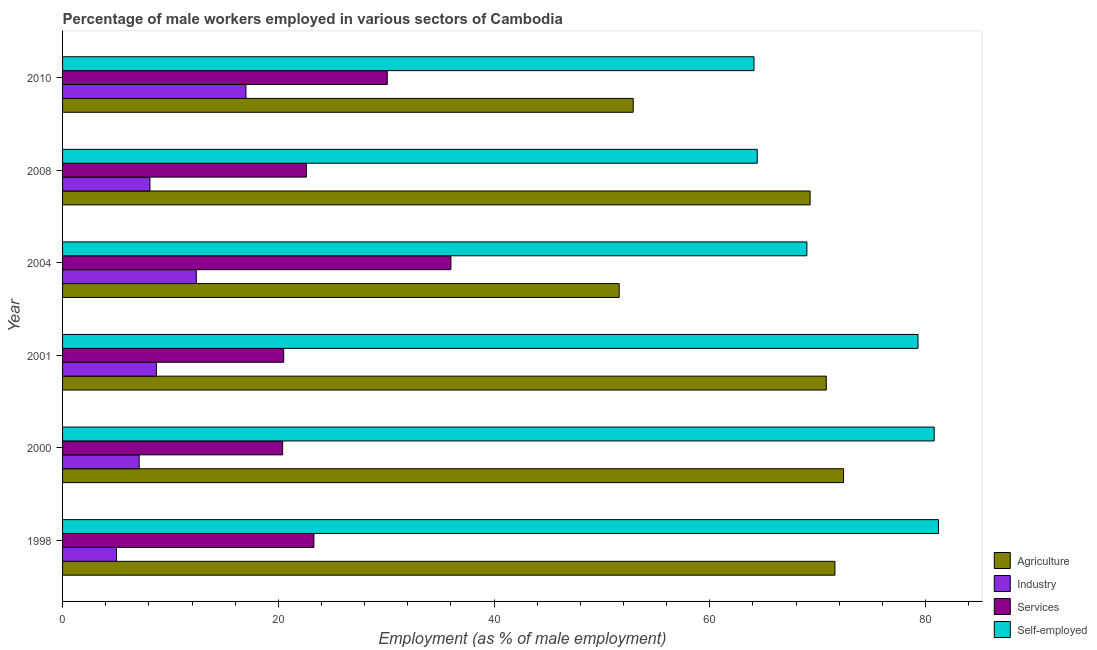Are the number of bars per tick equal to the number of legend labels?
Provide a succinct answer. Yes. How many bars are there on the 6th tick from the bottom?
Ensure brevity in your answer.  4. In how many cases, is the number of bars for a given year not equal to the number of legend labels?
Your answer should be very brief. 0. Across all years, what is the minimum percentage of male workers in agriculture?
Provide a succinct answer. 51.6. What is the total percentage of male workers in industry in the graph?
Your answer should be compact. 58.3. What is the difference between the percentage of male workers in services in 2008 and that in 2010?
Your response must be concise. -7.5. What is the difference between the percentage of male workers in services in 2000 and the percentage of self employed male workers in 2010?
Your response must be concise. -43.7. What is the average percentage of male workers in services per year?
Offer a terse response. 25.48. In the year 2008, what is the difference between the percentage of male workers in industry and percentage of male workers in agriculture?
Keep it short and to the point. -61.2. What is the ratio of the percentage of male workers in industry in 2004 to that in 2008?
Give a very brief answer. 1.53. Is the percentage of male workers in industry in 2000 less than that in 2004?
Offer a terse response. Yes. Is the difference between the percentage of male workers in services in 1998 and 2001 greater than the difference between the percentage of male workers in industry in 1998 and 2001?
Provide a short and direct response. Yes. What is the difference between the highest and the lowest percentage of self employed male workers?
Make the answer very short. 17.1. In how many years, is the percentage of male workers in industry greater than the average percentage of male workers in industry taken over all years?
Offer a terse response. 2. Is the sum of the percentage of male workers in industry in 1998 and 2010 greater than the maximum percentage of male workers in services across all years?
Offer a very short reply. No. Is it the case that in every year, the sum of the percentage of male workers in services and percentage of self employed male workers is greater than the sum of percentage of male workers in agriculture and percentage of male workers in industry?
Make the answer very short. Yes. What does the 2nd bar from the top in 2001 represents?
Your answer should be compact. Services. What does the 1st bar from the bottom in 2004 represents?
Your answer should be very brief. Agriculture. Are all the bars in the graph horizontal?
Offer a very short reply. Yes. Are the values on the major ticks of X-axis written in scientific E-notation?
Provide a succinct answer. No. Does the graph contain any zero values?
Offer a terse response. No. How many legend labels are there?
Give a very brief answer. 4. How are the legend labels stacked?
Offer a very short reply. Vertical. What is the title of the graph?
Offer a very short reply. Percentage of male workers employed in various sectors of Cambodia. Does "Gender equality" appear as one of the legend labels in the graph?
Your answer should be very brief. No. What is the label or title of the X-axis?
Provide a succinct answer. Employment (as % of male employment). What is the label or title of the Y-axis?
Offer a very short reply. Year. What is the Employment (as % of male employment) of Agriculture in 1998?
Provide a short and direct response. 71.6. What is the Employment (as % of male employment) of Industry in 1998?
Keep it short and to the point. 5. What is the Employment (as % of male employment) of Services in 1998?
Your answer should be very brief. 23.3. What is the Employment (as % of male employment) of Self-employed in 1998?
Your answer should be very brief. 81.2. What is the Employment (as % of male employment) of Agriculture in 2000?
Ensure brevity in your answer.  72.4. What is the Employment (as % of male employment) in Industry in 2000?
Keep it short and to the point. 7.1. What is the Employment (as % of male employment) of Services in 2000?
Your response must be concise. 20.4. What is the Employment (as % of male employment) of Self-employed in 2000?
Ensure brevity in your answer.  80.8. What is the Employment (as % of male employment) of Agriculture in 2001?
Provide a succinct answer. 70.8. What is the Employment (as % of male employment) in Industry in 2001?
Ensure brevity in your answer.  8.7. What is the Employment (as % of male employment) of Self-employed in 2001?
Offer a very short reply. 79.3. What is the Employment (as % of male employment) of Agriculture in 2004?
Your answer should be very brief. 51.6. What is the Employment (as % of male employment) of Industry in 2004?
Give a very brief answer. 12.4. What is the Employment (as % of male employment) in Services in 2004?
Give a very brief answer. 36. What is the Employment (as % of male employment) in Self-employed in 2004?
Offer a terse response. 69. What is the Employment (as % of male employment) of Agriculture in 2008?
Your response must be concise. 69.3. What is the Employment (as % of male employment) in Industry in 2008?
Make the answer very short. 8.1. What is the Employment (as % of male employment) in Services in 2008?
Ensure brevity in your answer.  22.6. What is the Employment (as % of male employment) in Self-employed in 2008?
Provide a succinct answer. 64.4. What is the Employment (as % of male employment) in Agriculture in 2010?
Give a very brief answer. 52.9. What is the Employment (as % of male employment) of Services in 2010?
Provide a short and direct response. 30.1. What is the Employment (as % of male employment) of Self-employed in 2010?
Ensure brevity in your answer.  64.1. Across all years, what is the maximum Employment (as % of male employment) in Agriculture?
Keep it short and to the point. 72.4. Across all years, what is the maximum Employment (as % of male employment) of Industry?
Offer a terse response. 17. Across all years, what is the maximum Employment (as % of male employment) in Self-employed?
Your answer should be compact. 81.2. Across all years, what is the minimum Employment (as % of male employment) in Agriculture?
Provide a short and direct response. 51.6. Across all years, what is the minimum Employment (as % of male employment) of Industry?
Provide a succinct answer. 5. Across all years, what is the minimum Employment (as % of male employment) in Services?
Give a very brief answer. 20.4. Across all years, what is the minimum Employment (as % of male employment) of Self-employed?
Your response must be concise. 64.1. What is the total Employment (as % of male employment) in Agriculture in the graph?
Make the answer very short. 388.6. What is the total Employment (as % of male employment) in Industry in the graph?
Your response must be concise. 58.3. What is the total Employment (as % of male employment) of Services in the graph?
Keep it short and to the point. 152.9. What is the total Employment (as % of male employment) of Self-employed in the graph?
Keep it short and to the point. 438.8. What is the difference between the Employment (as % of male employment) in Agriculture in 1998 and that in 2000?
Make the answer very short. -0.8. What is the difference between the Employment (as % of male employment) of Industry in 1998 and that in 2000?
Give a very brief answer. -2.1. What is the difference between the Employment (as % of male employment) of Services in 1998 and that in 2000?
Your response must be concise. 2.9. What is the difference between the Employment (as % of male employment) of Self-employed in 1998 and that in 2000?
Offer a very short reply. 0.4. What is the difference between the Employment (as % of male employment) in Services in 1998 and that in 2001?
Ensure brevity in your answer.  2.8. What is the difference between the Employment (as % of male employment) in Self-employed in 1998 and that in 2001?
Offer a terse response. 1.9. What is the difference between the Employment (as % of male employment) of Agriculture in 1998 and that in 2004?
Offer a very short reply. 20. What is the difference between the Employment (as % of male employment) of Services in 1998 and that in 2004?
Your response must be concise. -12.7. What is the difference between the Employment (as % of male employment) in Industry in 1998 and that in 2008?
Your answer should be very brief. -3.1. What is the difference between the Employment (as % of male employment) of Services in 1998 and that in 2008?
Keep it short and to the point. 0.7. What is the difference between the Employment (as % of male employment) in Industry in 1998 and that in 2010?
Your response must be concise. -12. What is the difference between the Employment (as % of male employment) of Self-employed in 1998 and that in 2010?
Provide a short and direct response. 17.1. What is the difference between the Employment (as % of male employment) of Agriculture in 2000 and that in 2001?
Keep it short and to the point. 1.6. What is the difference between the Employment (as % of male employment) in Industry in 2000 and that in 2001?
Offer a very short reply. -1.6. What is the difference between the Employment (as % of male employment) of Self-employed in 2000 and that in 2001?
Your response must be concise. 1.5. What is the difference between the Employment (as % of male employment) of Agriculture in 2000 and that in 2004?
Make the answer very short. 20.8. What is the difference between the Employment (as % of male employment) in Industry in 2000 and that in 2004?
Provide a succinct answer. -5.3. What is the difference between the Employment (as % of male employment) in Services in 2000 and that in 2004?
Offer a terse response. -15.6. What is the difference between the Employment (as % of male employment) of Agriculture in 2000 and that in 2008?
Your answer should be very brief. 3.1. What is the difference between the Employment (as % of male employment) in Services in 2000 and that in 2010?
Your response must be concise. -9.7. What is the difference between the Employment (as % of male employment) of Self-employed in 2000 and that in 2010?
Provide a succinct answer. 16.7. What is the difference between the Employment (as % of male employment) of Agriculture in 2001 and that in 2004?
Your answer should be compact. 19.2. What is the difference between the Employment (as % of male employment) of Services in 2001 and that in 2004?
Provide a succinct answer. -15.5. What is the difference between the Employment (as % of male employment) of Agriculture in 2001 and that in 2008?
Your answer should be very brief. 1.5. What is the difference between the Employment (as % of male employment) of Industry in 2001 and that in 2008?
Offer a very short reply. 0.6. What is the difference between the Employment (as % of male employment) in Services in 2001 and that in 2008?
Make the answer very short. -2.1. What is the difference between the Employment (as % of male employment) of Self-employed in 2001 and that in 2008?
Provide a succinct answer. 14.9. What is the difference between the Employment (as % of male employment) of Self-employed in 2001 and that in 2010?
Provide a succinct answer. 15.2. What is the difference between the Employment (as % of male employment) in Agriculture in 2004 and that in 2008?
Your response must be concise. -17.7. What is the difference between the Employment (as % of male employment) in Self-employed in 2004 and that in 2008?
Provide a short and direct response. 4.6. What is the difference between the Employment (as % of male employment) in Self-employed in 2004 and that in 2010?
Keep it short and to the point. 4.9. What is the difference between the Employment (as % of male employment) in Agriculture in 2008 and that in 2010?
Offer a terse response. 16.4. What is the difference between the Employment (as % of male employment) of Industry in 2008 and that in 2010?
Your answer should be compact. -8.9. What is the difference between the Employment (as % of male employment) of Agriculture in 1998 and the Employment (as % of male employment) of Industry in 2000?
Give a very brief answer. 64.5. What is the difference between the Employment (as % of male employment) in Agriculture in 1998 and the Employment (as % of male employment) in Services in 2000?
Give a very brief answer. 51.2. What is the difference between the Employment (as % of male employment) in Industry in 1998 and the Employment (as % of male employment) in Services in 2000?
Keep it short and to the point. -15.4. What is the difference between the Employment (as % of male employment) of Industry in 1998 and the Employment (as % of male employment) of Self-employed in 2000?
Your answer should be compact. -75.8. What is the difference between the Employment (as % of male employment) in Services in 1998 and the Employment (as % of male employment) in Self-employed in 2000?
Offer a very short reply. -57.5. What is the difference between the Employment (as % of male employment) of Agriculture in 1998 and the Employment (as % of male employment) of Industry in 2001?
Ensure brevity in your answer.  62.9. What is the difference between the Employment (as % of male employment) of Agriculture in 1998 and the Employment (as % of male employment) of Services in 2001?
Your answer should be very brief. 51.1. What is the difference between the Employment (as % of male employment) in Agriculture in 1998 and the Employment (as % of male employment) in Self-employed in 2001?
Make the answer very short. -7.7. What is the difference between the Employment (as % of male employment) in Industry in 1998 and the Employment (as % of male employment) in Services in 2001?
Provide a short and direct response. -15.5. What is the difference between the Employment (as % of male employment) in Industry in 1998 and the Employment (as % of male employment) in Self-employed in 2001?
Keep it short and to the point. -74.3. What is the difference between the Employment (as % of male employment) in Services in 1998 and the Employment (as % of male employment) in Self-employed in 2001?
Offer a very short reply. -56. What is the difference between the Employment (as % of male employment) of Agriculture in 1998 and the Employment (as % of male employment) of Industry in 2004?
Your response must be concise. 59.2. What is the difference between the Employment (as % of male employment) in Agriculture in 1998 and the Employment (as % of male employment) in Services in 2004?
Your response must be concise. 35.6. What is the difference between the Employment (as % of male employment) in Industry in 1998 and the Employment (as % of male employment) in Services in 2004?
Make the answer very short. -31. What is the difference between the Employment (as % of male employment) in Industry in 1998 and the Employment (as % of male employment) in Self-employed in 2004?
Your answer should be very brief. -64. What is the difference between the Employment (as % of male employment) in Services in 1998 and the Employment (as % of male employment) in Self-employed in 2004?
Offer a terse response. -45.7. What is the difference between the Employment (as % of male employment) of Agriculture in 1998 and the Employment (as % of male employment) of Industry in 2008?
Keep it short and to the point. 63.5. What is the difference between the Employment (as % of male employment) in Agriculture in 1998 and the Employment (as % of male employment) in Self-employed in 2008?
Provide a short and direct response. 7.2. What is the difference between the Employment (as % of male employment) of Industry in 1998 and the Employment (as % of male employment) of Services in 2008?
Offer a terse response. -17.6. What is the difference between the Employment (as % of male employment) in Industry in 1998 and the Employment (as % of male employment) in Self-employed in 2008?
Provide a succinct answer. -59.4. What is the difference between the Employment (as % of male employment) in Services in 1998 and the Employment (as % of male employment) in Self-employed in 2008?
Ensure brevity in your answer.  -41.1. What is the difference between the Employment (as % of male employment) of Agriculture in 1998 and the Employment (as % of male employment) of Industry in 2010?
Ensure brevity in your answer.  54.6. What is the difference between the Employment (as % of male employment) in Agriculture in 1998 and the Employment (as % of male employment) in Services in 2010?
Your response must be concise. 41.5. What is the difference between the Employment (as % of male employment) of Industry in 1998 and the Employment (as % of male employment) of Services in 2010?
Your response must be concise. -25.1. What is the difference between the Employment (as % of male employment) of Industry in 1998 and the Employment (as % of male employment) of Self-employed in 2010?
Your response must be concise. -59.1. What is the difference between the Employment (as % of male employment) of Services in 1998 and the Employment (as % of male employment) of Self-employed in 2010?
Give a very brief answer. -40.8. What is the difference between the Employment (as % of male employment) in Agriculture in 2000 and the Employment (as % of male employment) in Industry in 2001?
Offer a terse response. 63.7. What is the difference between the Employment (as % of male employment) in Agriculture in 2000 and the Employment (as % of male employment) in Services in 2001?
Provide a short and direct response. 51.9. What is the difference between the Employment (as % of male employment) of Agriculture in 2000 and the Employment (as % of male employment) of Self-employed in 2001?
Give a very brief answer. -6.9. What is the difference between the Employment (as % of male employment) of Industry in 2000 and the Employment (as % of male employment) of Self-employed in 2001?
Your response must be concise. -72.2. What is the difference between the Employment (as % of male employment) in Services in 2000 and the Employment (as % of male employment) in Self-employed in 2001?
Make the answer very short. -58.9. What is the difference between the Employment (as % of male employment) of Agriculture in 2000 and the Employment (as % of male employment) of Services in 2004?
Give a very brief answer. 36.4. What is the difference between the Employment (as % of male employment) in Industry in 2000 and the Employment (as % of male employment) in Services in 2004?
Keep it short and to the point. -28.9. What is the difference between the Employment (as % of male employment) of Industry in 2000 and the Employment (as % of male employment) of Self-employed in 2004?
Your answer should be very brief. -61.9. What is the difference between the Employment (as % of male employment) of Services in 2000 and the Employment (as % of male employment) of Self-employed in 2004?
Give a very brief answer. -48.6. What is the difference between the Employment (as % of male employment) in Agriculture in 2000 and the Employment (as % of male employment) in Industry in 2008?
Provide a short and direct response. 64.3. What is the difference between the Employment (as % of male employment) of Agriculture in 2000 and the Employment (as % of male employment) of Services in 2008?
Offer a very short reply. 49.8. What is the difference between the Employment (as % of male employment) in Agriculture in 2000 and the Employment (as % of male employment) in Self-employed in 2008?
Make the answer very short. 8. What is the difference between the Employment (as % of male employment) of Industry in 2000 and the Employment (as % of male employment) of Services in 2008?
Provide a short and direct response. -15.5. What is the difference between the Employment (as % of male employment) in Industry in 2000 and the Employment (as % of male employment) in Self-employed in 2008?
Your answer should be very brief. -57.3. What is the difference between the Employment (as % of male employment) in Services in 2000 and the Employment (as % of male employment) in Self-employed in 2008?
Your answer should be compact. -44. What is the difference between the Employment (as % of male employment) of Agriculture in 2000 and the Employment (as % of male employment) of Industry in 2010?
Your response must be concise. 55.4. What is the difference between the Employment (as % of male employment) in Agriculture in 2000 and the Employment (as % of male employment) in Services in 2010?
Your answer should be very brief. 42.3. What is the difference between the Employment (as % of male employment) in Agriculture in 2000 and the Employment (as % of male employment) in Self-employed in 2010?
Ensure brevity in your answer.  8.3. What is the difference between the Employment (as % of male employment) of Industry in 2000 and the Employment (as % of male employment) of Services in 2010?
Make the answer very short. -23. What is the difference between the Employment (as % of male employment) of Industry in 2000 and the Employment (as % of male employment) of Self-employed in 2010?
Your answer should be compact. -57. What is the difference between the Employment (as % of male employment) of Services in 2000 and the Employment (as % of male employment) of Self-employed in 2010?
Offer a very short reply. -43.7. What is the difference between the Employment (as % of male employment) of Agriculture in 2001 and the Employment (as % of male employment) of Industry in 2004?
Provide a succinct answer. 58.4. What is the difference between the Employment (as % of male employment) in Agriculture in 2001 and the Employment (as % of male employment) in Services in 2004?
Your response must be concise. 34.8. What is the difference between the Employment (as % of male employment) in Industry in 2001 and the Employment (as % of male employment) in Services in 2004?
Your response must be concise. -27.3. What is the difference between the Employment (as % of male employment) of Industry in 2001 and the Employment (as % of male employment) of Self-employed in 2004?
Your answer should be compact. -60.3. What is the difference between the Employment (as % of male employment) in Services in 2001 and the Employment (as % of male employment) in Self-employed in 2004?
Offer a very short reply. -48.5. What is the difference between the Employment (as % of male employment) in Agriculture in 2001 and the Employment (as % of male employment) in Industry in 2008?
Your answer should be very brief. 62.7. What is the difference between the Employment (as % of male employment) of Agriculture in 2001 and the Employment (as % of male employment) of Services in 2008?
Your answer should be very brief. 48.2. What is the difference between the Employment (as % of male employment) in Industry in 2001 and the Employment (as % of male employment) in Self-employed in 2008?
Provide a succinct answer. -55.7. What is the difference between the Employment (as % of male employment) in Services in 2001 and the Employment (as % of male employment) in Self-employed in 2008?
Give a very brief answer. -43.9. What is the difference between the Employment (as % of male employment) of Agriculture in 2001 and the Employment (as % of male employment) of Industry in 2010?
Ensure brevity in your answer.  53.8. What is the difference between the Employment (as % of male employment) of Agriculture in 2001 and the Employment (as % of male employment) of Services in 2010?
Your answer should be compact. 40.7. What is the difference between the Employment (as % of male employment) in Industry in 2001 and the Employment (as % of male employment) in Services in 2010?
Give a very brief answer. -21.4. What is the difference between the Employment (as % of male employment) of Industry in 2001 and the Employment (as % of male employment) of Self-employed in 2010?
Provide a succinct answer. -55.4. What is the difference between the Employment (as % of male employment) of Services in 2001 and the Employment (as % of male employment) of Self-employed in 2010?
Your answer should be very brief. -43.6. What is the difference between the Employment (as % of male employment) of Agriculture in 2004 and the Employment (as % of male employment) of Industry in 2008?
Your response must be concise. 43.5. What is the difference between the Employment (as % of male employment) of Agriculture in 2004 and the Employment (as % of male employment) of Self-employed in 2008?
Make the answer very short. -12.8. What is the difference between the Employment (as % of male employment) of Industry in 2004 and the Employment (as % of male employment) of Self-employed in 2008?
Give a very brief answer. -52. What is the difference between the Employment (as % of male employment) in Services in 2004 and the Employment (as % of male employment) in Self-employed in 2008?
Your answer should be compact. -28.4. What is the difference between the Employment (as % of male employment) of Agriculture in 2004 and the Employment (as % of male employment) of Industry in 2010?
Provide a short and direct response. 34.6. What is the difference between the Employment (as % of male employment) of Agriculture in 2004 and the Employment (as % of male employment) of Self-employed in 2010?
Keep it short and to the point. -12.5. What is the difference between the Employment (as % of male employment) of Industry in 2004 and the Employment (as % of male employment) of Services in 2010?
Provide a short and direct response. -17.7. What is the difference between the Employment (as % of male employment) of Industry in 2004 and the Employment (as % of male employment) of Self-employed in 2010?
Your answer should be compact. -51.7. What is the difference between the Employment (as % of male employment) in Services in 2004 and the Employment (as % of male employment) in Self-employed in 2010?
Offer a very short reply. -28.1. What is the difference between the Employment (as % of male employment) of Agriculture in 2008 and the Employment (as % of male employment) of Industry in 2010?
Provide a succinct answer. 52.3. What is the difference between the Employment (as % of male employment) of Agriculture in 2008 and the Employment (as % of male employment) of Services in 2010?
Provide a short and direct response. 39.2. What is the difference between the Employment (as % of male employment) in Agriculture in 2008 and the Employment (as % of male employment) in Self-employed in 2010?
Offer a very short reply. 5.2. What is the difference between the Employment (as % of male employment) of Industry in 2008 and the Employment (as % of male employment) of Self-employed in 2010?
Offer a terse response. -56. What is the difference between the Employment (as % of male employment) in Services in 2008 and the Employment (as % of male employment) in Self-employed in 2010?
Your answer should be very brief. -41.5. What is the average Employment (as % of male employment) of Agriculture per year?
Your answer should be very brief. 64.77. What is the average Employment (as % of male employment) of Industry per year?
Your answer should be compact. 9.72. What is the average Employment (as % of male employment) in Services per year?
Your answer should be compact. 25.48. What is the average Employment (as % of male employment) in Self-employed per year?
Keep it short and to the point. 73.13. In the year 1998, what is the difference between the Employment (as % of male employment) of Agriculture and Employment (as % of male employment) of Industry?
Offer a very short reply. 66.6. In the year 1998, what is the difference between the Employment (as % of male employment) of Agriculture and Employment (as % of male employment) of Services?
Ensure brevity in your answer.  48.3. In the year 1998, what is the difference between the Employment (as % of male employment) of Agriculture and Employment (as % of male employment) of Self-employed?
Your answer should be compact. -9.6. In the year 1998, what is the difference between the Employment (as % of male employment) in Industry and Employment (as % of male employment) in Services?
Provide a succinct answer. -18.3. In the year 1998, what is the difference between the Employment (as % of male employment) of Industry and Employment (as % of male employment) of Self-employed?
Make the answer very short. -76.2. In the year 1998, what is the difference between the Employment (as % of male employment) in Services and Employment (as % of male employment) in Self-employed?
Offer a terse response. -57.9. In the year 2000, what is the difference between the Employment (as % of male employment) in Agriculture and Employment (as % of male employment) in Industry?
Keep it short and to the point. 65.3. In the year 2000, what is the difference between the Employment (as % of male employment) of Agriculture and Employment (as % of male employment) of Services?
Ensure brevity in your answer.  52. In the year 2000, what is the difference between the Employment (as % of male employment) of Agriculture and Employment (as % of male employment) of Self-employed?
Provide a short and direct response. -8.4. In the year 2000, what is the difference between the Employment (as % of male employment) of Industry and Employment (as % of male employment) of Services?
Provide a succinct answer. -13.3. In the year 2000, what is the difference between the Employment (as % of male employment) of Industry and Employment (as % of male employment) of Self-employed?
Offer a very short reply. -73.7. In the year 2000, what is the difference between the Employment (as % of male employment) in Services and Employment (as % of male employment) in Self-employed?
Ensure brevity in your answer.  -60.4. In the year 2001, what is the difference between the Employment (as % of male employment) of Agriculture and Employment (as % of male employment) of Industry?
Make the answer very short. 62.1. In the year 2001, what is the difference between the Employment (as % of male employment) in Agriculture and Employment (as % of male employment) in Services?
Make the answer very short. 50.3. In the year 2001, what is the difference between the Employment (as % of male employment) in Industry and Employment (as % of male employment) in Self-employed?
Your response must be concise. -70.6. In the year 2001, what is the difference between the Employment (as % of male employment) of Services and Employment (as % of male employment) of Self-employed?
Provide a succinct answer. -58.8. In the year 2004, what is the difference between the Employment (as % of male employment) in Agriculture and Employment (as % of male employment) in Industry?
Keep it short and to the point. 39.2. In the year 2004, what is the difference between the Employment (as % of male employment) of Agriculture and Employment (as % of male employment) of Self-employed?
Provide a succinct answer. -17.4. In the year 2004, what is the difference between the Employment (as % of male employment) in Industry and Employment (as % of male employment) in Services?
Your answer should be very brief. -23.6. In the year 2004, what is the difference between the Employment (as % of male employment) of Industry and Employment (as % of male employment) of Self-employed?
Ensure brevity in your answer.  -56.6. In the year 2004, what is the difference between the Employment (as % of male employment) of Services and Employment (as % of male employment) of Self-employed?
Your response must be concise. -33. In the year 2008, what is the difference between the Employment (as % of male employment) of Agriculture and Employment (as % of male employment) of Industry?
Offer a very short reply. 61.2. In the year 2008, what is the difference between the Employment (as % of male employment) of Agriculture and Employment (as % of male employment) of Services?
Keep it short and to the point. 46.7. In the year 2008, what is the difference between the Employment (as % of male employment) in Agriculture and Employment (as % of male employment) in Self-employed?
Offer a very short reply. 4.9. In the year 2008, what is the difference between the Employment (as % of male employment) of Industry and Employment (as % of male employment) of Services?
Offer a terse response. -14.5. In the year 2008, what is the difference between the Employment (as % of male employment) in Industry and Employment (as % of male employment) in Self-employed?
Keep it short and to the point. -56.3. In the year 2008, what is the difference between the Employment (as % of male employment) in Services and Employment (as % of male employment) in Self-employed?
Your response must be concise. -41.8. In the year 2010, what is the difference between the Employment (as % of male employment) of Agriculture and Employment (as % of male employment) of Industry?
Ensure brevity in your answer.  35.9. In the year 2010, what is the difference between the Employment (as % of male employment) in Agriculture and Employment (as % of male employment) in Services?
Make the answer very short. 22.8. In the year 2010, what is the difference between the Employment (as % of male employment) of Industry and Employment (as % of male employment) of Services?
Make the answer very short. -13.1. In the year 2010, what is the difference between the Employment (as % of male employment) of Industry and Employment (as % of male employment) of Self-employed?
Offer a terse response. -47.1. In the year 2010, what is the difference between the Employment (as % of male employment) of Services and Employment (as % of male employment) of Self-employed?
Provide a succinct answer. -34. What is the ratio of the Employment (as % of male employment) of Agriculture in 1998 to that in 2000?
Your answer should be very brief. 0.99. What is the ratio of the Employment (as % of male employment) in Industry in 1998 to that in 2000?
Give a very brief answer. 0.7. What is the ratio of the Employment (as % of male employment) in Services in 1998 to that in 2000?
Offer a terse response. 1.14. What is the ratio of the Employment (as % of male employment) of Self-employed in 1998 to that in 2000?
Your response must be concise. 1. What is the ratio of the Employment (as % of male employment) of Agriculture in 1998 to that in 2001?
Keep it short and to the point. 1.01. What is the ratio of the Employment (as % of male employment) of Industry in 1998 to that in 2001?
Your answer should be compact. 0.57. What is the ratio of the Employment (as % of male employment) of Services in 1998 to that in 2001?
Ensure brevity in your answer.  1.14. What is the ratio of the Employment (as % of male employment) of Self-employed in 1998 to that in 2001?
Your answer should be very brief. 1.02. What is the ratio of the Employment (as % of male employment) in Agriculture in 1998 to that in 2004?
Give a very brief answer. 1.39. What is the ratio of the Employment (as % of male employment) of Industry in 1998 to that in 2004?
Your response must be concise. 0.4. What is the ratio of the Employment (as % of male employment) in Services in 1998 to that in 2004?
Give a very brief answer. 0.65. What is the ratio of the Employment (as % of male employment) of Self-employed in 1998 to that in 2004?
Offer a very short reply. 1.18. What is the ratio of the Employment (as % of male employment) of Agriculture in 1998 to that in 2008?
Give a very brief answer. 1.03. What is the ratio of the Employment (as % of male employment) of Industry in 1998 to that in 2008?
Offer a terse response. 0.62. What is the ratio of the Employment (as % of male employment) in Services in 1998 to that in 2008?
Offer a very short reply. 1.03. What is the ratio of the Employment (as % of male employment) of Self-employed in 1998 to that in 2008?
Ensure brevity in your answer.  1.26. What is the ratio of the Employment (as % of male employment) in Agriculture in 1998 to that in 2010?
Ensure brevity in your answer.  1.35. What is the ratio of the Employment (as % of male employment) in Industry in 1998 to that in 2010?
Make the answer very short. 0.29. What is the ratio of the Employment (as % of male employment) of Services in 1998 to that in 2010?
Offer a very short reply. 0.77. What is the ratio of the Employment (as % of male employment) in Self-employed in 1998 to that in 2010?
Offer a very short reply. 1.27. What is the ratio of the Employment (as % of male employment) of Agriculture in 2000 to that in 2001?
Keep it short and to the point. 1.02. What is the ratio of the Employment (as % of male employment) in Industry in 2000 to that in 2001?
Offer a terse response. 0.82. What is the ratio of the Employment (as % of male employment) of Self-employed in 2000 to that in 2001?
Make the answer very short. 1.02. What is the ratio of the Employment (as % of male employment) in Agriculture in 2000 to that in 2004?
Offer a very short reply. 1.4. What is the ratio of the Employment (as % of male employment) in Industry in 2000 to that in 2004?
Offer a terse response. 0.57. What is the ratio of the Employment (as % of male employment) in Services in 2000 to that in 2004?
Offer a very short reply. 0.57. What is the ratio of the Employment (as % of male employment) in Self-employed in 2000 to that in 2004?
Keep it short and to the point. 1.17. What is the ratio of the Employment (as % of male employment) in Agriculture in 2000 to that in 2008?
Provide a succinct answer. 1.04. What is the ratio of the Employment (as % of male employment) in Industry in 2000 to that in 2008?
Make the answer very short. 0.88. What is the ratio of the Employment (as % of male employment) of Services in 2000 to that in 2008?
Give a very brief answer. 0.9. What is the ratio of the Employment (as % of male employment) of Self-employed in 2000 to that in 2008?
Offer a very short reply. 1.25. What is the ratio of the Employment (as % of male employment) in Agriculture in 2000 to that in 2010?
Your response must be concise. 1.37. What is the ratio of the Employment (as % of male employment) in Industry in 2000 to that in 2010?
Offer a very short reply. 0.42. What is the ratio of the Employment (as % of male employment) in Services in 2000 to that in 2010?
Provide a short and direct response. 0.68. What is the ratio of the Employment (as % of male employment) of Self-employed in 2000 to that in 2010?
Make the answer very short. 1.26. What is the ratio of the Employment (as % of male employment) of Agriculture in 2001 to that in 2004?
Keep it short and to the point. 1.37. What is the ratio of the Employment (as % of male employment) of Industry in 2001 to that in 2004?
Your answer should be compact. 0.7. What is the ratio of the Employment (as % of male employment) in Services in 2001 to that in 2004?
Give a very brief answer. 0.57. What is the ratio of the Employment (as % of male employment) in Self-employed in 2001 to that in 2004?
Give a very brief answer. 1.15. What is the ratio of the Employment (as % of male employment) in Agriculture in 2001 to that in 2008?
Give a very brief answer. 1.02. What is the ratio of the Employment (as % of male employment) in Industry in 2001 to that in 2008?
Your answer should be compact. 1.07. What is the ratio of the Employment (as % of male employment) of Services in 2001 to that in 2008?
Provide a succinct answer. 0.91. What is the ratio of the Employment (as % of male employment) in Self-employed in 2001 to that in 2008?
Keep it short and to the point. 1.23. What is the ratio of the Employment (as % of male employment) of Agriculture in 2001 to that in 2010?
Keep it short and to the point. 1.34. What is the ratio of the Employment (as % of male employment) of Industry in 2001 to that in 2010?
Provide a succinct answer. 0.51. What is the ratio of the Employment (as % of male employment) in Services in 2001 to that in 2010?
Provide a short and direct response. 0.68. What is the ratio of the Employment (as % of male employment) of Self-employed in 2001 to that in 2010?
Ensure brevity in your answer.  1.24. What is the ratio of the Employment (as % of male employment) in Agriculture in 2004 to that in 2008?
Your answer should be compact. 0.74. What is the ratio of the Employment (as % of male employment) of Industry in 2004 to that in 2008?
Make the answer very short. 1.53. What is the ratio of the Employment (as % of male employment) of Services in 2004 to that in 2008?
Your answer should be compact. 1.59. What is the ratio of the Employment (as % of male employment) of Self-employed in 2004 to that in 2008?
Offer a very short reply. 1.07. What is the ratio of the Employment (as % of male employment) of Agriculture in 2004 to that in 2010?
Give a very brief answer. 0.98. What is the ratio of the Employment (as % of male employment) of Industry in 2004 to that in 2010?
Keep it short and to the point. 0.73. What is the ratio of the Employment (as % of male employment) of Services in 2004 to that in 2010?
Offer a very short reply. 1.2. What is the ratio of the Employment (as % of male employment) in Self-employed in 2004 to that in 2010?
Provide a short and direct response. 1.08. What is the ratio of the Employment (as % of male employment) in Agriculture in 2008 to that in 2010?
Make the answer very short. 1.31. What is the ratio of the Employment (as % of male employment) of Industry in 2008 to that in 2010?
Offer a terse response. 0.48. What is the ratio of the Employment (as % of male employment) in Services in 2008 to that in 2010?
Offer a terse response. 0.75. What is the difference between the highest and the second highest Employment (as % of male employment) in Industry?
Make the answer very short. 4.6. What is the difference between the highest and the lowest Employment (as % of male employment) of Agriculture?
Your answer should be compact. 20.8. What is the difference between the highest and the lowest Employment (as % of male employment) in Industry?
Offer a very short reply. 12. What is the difference between the highest and the lowest Employment (as % of male employment) in Services?
Ensure brevity in your answer.  15.6. 